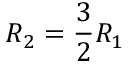Convert formula to latex. <formula><loc_0><loc_0><loc_500><loc_500>R _ { 2 } = \frac { 3 } { 2 } R _ { 1 }</formula> 